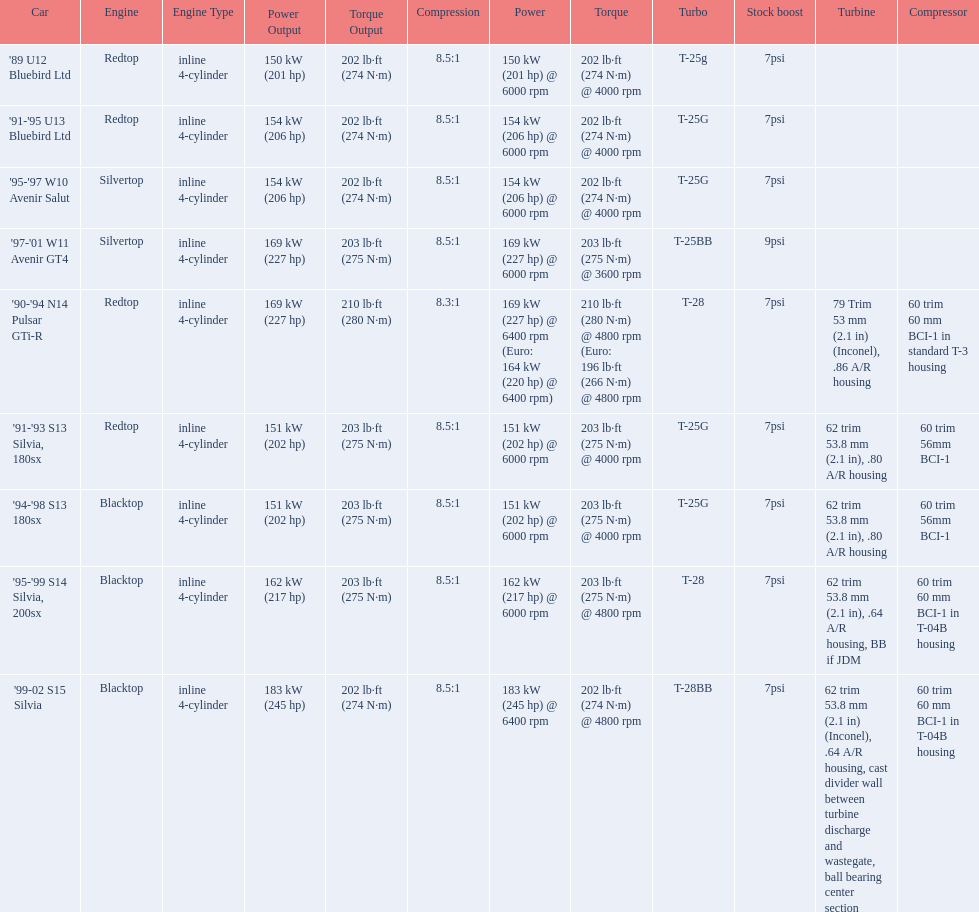Which cars list turbine details? '90-'94 N14 Pulsar GTi-R, '91-'93 S13 Silvia, 180sx, '94-'98 S13 180sx, '95-'99 S14 Silvia, 200sx, '99-02 S15 Silvia. Which of these hit their peak hp at the highest rpm? '90-'94 N14 Pulsar GTi-R, '99-02 S15 Silvia. Of those what is the compression of the only engine that isn't blacktop?? 8.3:1. Could you help me parse every detail presented in this table? {'header': ['Car', 'Engine', 'Engine Type', 'Power Output', 'Torque Output', 'Compression', 'Power', 'Torque', 'Turbo', 'Stock boost', 'Turbine', 'Compressor'], 'rows': [["'89 U12 Bluebird Ltd", 'Redtop', 'inline 4-cylinder', '150 kW (201 hp)', '202 lb·ft (274 N·m)', '8.5:1', '150\xa0kW (201\xa0hp) @ 6000 rpm', '202\xa0lb·ft (274\xa0N·m) @ 4000 rpm', 'T-25g', '7psi', '', ''], ["'91-'95 U13 Bluebird Ltd", 'Redtop', 'inline 4-cylinder', '154 kW (206 hp)', '202 lb·ft (274 N·m)', '8.5:1', '154\xa0kW (206\xa0hp) @ 6000 rpm', '202\xa0lb·ft (274\xa0N·m) @ 4000 rpm', 'T-25G', '7psi', '', ''], ["'95-'97 W10 Avenir Salut", 'Silvertop', 'inline 4-cylinder', '154 kW (206 hp)', '202 lb·ft (274 N·m)', '8.5:1', '154\xa0kW (206\xa0hp) @ 6000 rpm', '202\xa0lb·ft (274\xa0N·m) @ 4000 rpm', 'T-25G', '7psi', '', ''], ["'97-'01 W11 Avenir GT4", 'Silvertop', 'inline 4-cylinder', '169 kW (227 hp)', '203 lb·ft (275 N·m)', '8.5:1', '169\xa0kW (227\xa0hp) @ 6000 rpm', '203\xa0lb·ft (275\xa0N·m) @ 3600 rpm', 'T-25BB', '9psi', '', ''], ["'90-'94 N14 Pulsar GTi-R", 'Redtop', 'inline 4-cylinder', '169 kW (227 hp)', '210 lb·ft (280 N·m)', '8.3:1', '169\xa0kW (227\xa0hp) @ 6400 rpm (Euro: 164\xa0kW (220\xa0hp) @ 6400 rpm)', '210\xa0lb·ft (280\xa0N·m) @ 4800 rpm (Euro: 196\xa0lb·ft (266\xa0N·m) @ 4800 rpm', 'T-28', '7psi', '79 Trim 53\xa0mm (2.1\xa0in) (Inconel), .86 A/R housing', '60 trim 60\xa0mm BCI-1 in standard T-3 housing'], ["'91-'93 S13 Silvia, 180sx", 'Redtop', 'inline 4-cylinder', '151 kW (202 hp)', '203 lb·ft (275 N·m)', '8.5:1', '151\xa0kW (202\xa0hp) @ 6000 rpm', '203\xa0lb·ft (275\xa0N·m) @ 4000 rpm', 'T-25G', '7psi', '62 trim 53.8\xa0mm (2.1\xa0in), .80 A/R housing', '60 trim 56mm BCI-1'], ["'94-'98 S13 180sx", 'Blacktop', 'inline 4-cylinder', '151 kW (202 hp)', '203 lb·ft (275 N·m)', '8.5:1', '151\xa0kW (202\xa0hp) @ 6000 rpm', '203\xa0lb·ft (275\xa0N·m) @ 4000 rpm', 'T-25G', '7psi', '62 trim 53.8\xa0mm (2.1\xa0in), .80 A/R housing', '60 trim 56mm BCI-1'], ["'95-'99 S14 Silvia, 200sx", 'Blacktop', 'inline 4-cylinder', '162 kW (217 hp)', '203 lb·ft (275 N·m)', '8.5:1', '162\xa0kW (217\xa0hp) @ 6000 rpm', '203\xa0lb·ft (275\xa0N·m) @ 4800 rpm', 'T-28', '7psi', '62 trim 53.8\xa0mm (2.1\xa0in), .64 A/R housing, BB if JDM', '60 trim 60\xa0mm BCI-1 in T-04B housing'], ["'99-02 S15 Silvia", 'Blacktop', 'inline 4-cylinder', '183 kW (245 hp)', '202 lb·ft (274 N·m)', '8.5:1', '183\xa0kW (245\xa0hp) @ 6400 rpm', '202\xa0lb·ft (274\xa0N·m) @ 4800 rpm', 'T-28BB', '7psi', '62 trim 53.8\xa0mm (2.1\xa0in) (Inconel), .64 A/R housing, cast divider wall between turbine discharge and wastegate, ball bearing center section', '60 trim 60\xa0mm BCI-1 in T-04B housing']]} 